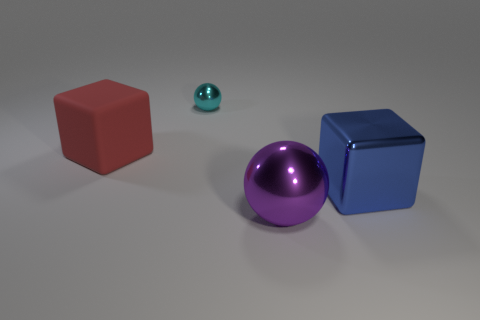Is there an object that is on the right side of the big red thing to the left of the block that is right of the red block? Yes, there is a small, glossy, teal-colored sphere situated to the right of the large red cube, which in turn is to the left of the large blue cube that you have mentioned. 